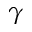Convert formula to latex. <formula><loc_0><loc_0><loc_500><loc_500>\gamma</formula> 